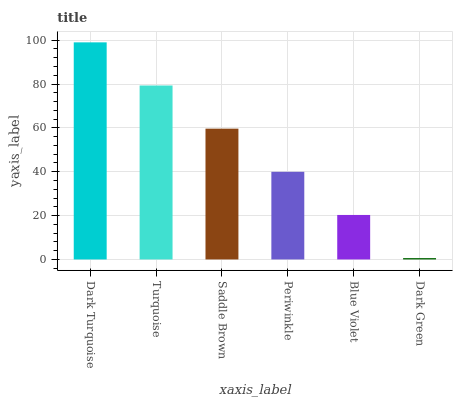Is Dark Green the minimum?
Answer yes or no. Yes. Is Dark Turquoise the maximum?
Answer yes or no. Yes. Is Turquoise the minimum?
Answer yes or no. No. Is Turquoise the maximum?
Answer yes or no. No. Is Dark Turquoise greater than Turquoise?
Answer yes or no. Yes. Is Turquoise less than Dark Turquoise?
Answer yes or no. Yes. Is Turquoise greater than Dark Turquoise?
Answer yes or no. No. Is Dark Turquoise less than Turquoise?
Answer yes or no. No. Is Saddle Brown the high median?
Answer yes or no. Yes. Is Periwinkle the low median?
Answer yes or no. Yes. Is Turquoise the high median?
Answer yes or no. No. Is Dark Turquoise the low median?
Answer yes or no. No. 